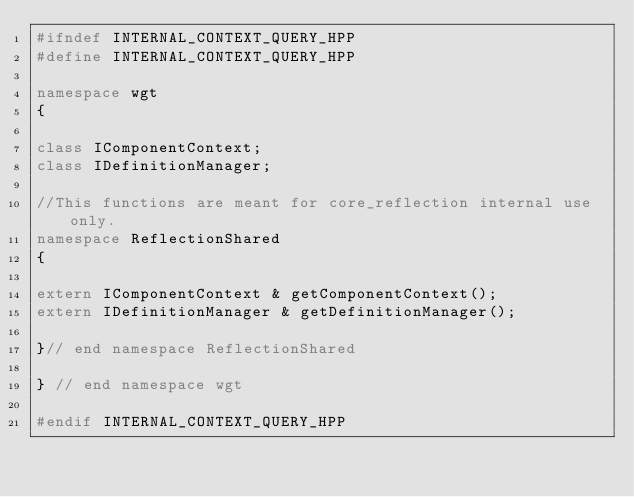<code> <loc_0><loc_0><loc_500><loc_500><_C++_>#ifndef INTERNAL_CONTEXT_QUERY_HPP
#define INTERNAL_CONTEXT_QUERY_HPP

namespace wgt
{

class IComponentContext;
class IDefinitionManager;

//This functions are meant for core_reflection internal use only.
namespace ReflectionShared
{

extern IComponentContext & getComponentContext();
extern IDefinitionManager & getDefinitionManager();

}// end namespace ReflectionShared

} // end namespace wgt

#endif INTERNAL_CONTEXT_QUERY_HPP</code> 